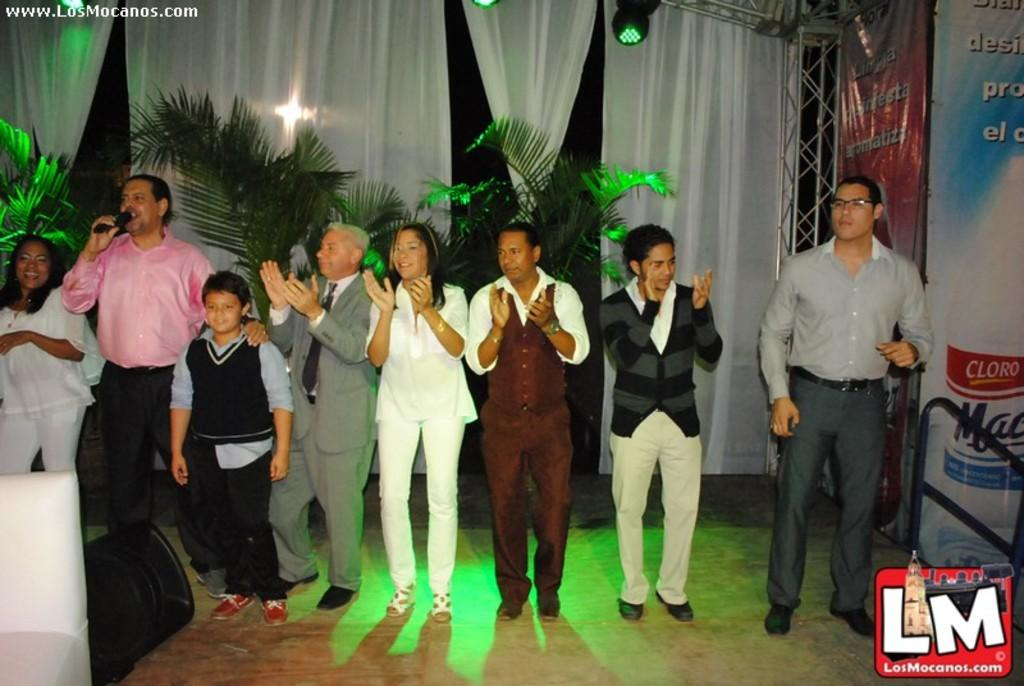How many people are in the image? There are persons in the image, but the exact number is not specified. What are some of the people doing in the image? Some of the persons are clapping. What object is being held by one of the persons? One person is holding a microphone. What type of clothing can be seen in the background of the image? There are pants in the background of the image. What type of window treatment is visible in the background of the image? There are curtains in the background of the image. What is located at the top of the image? There are lights at the top of the image. How many children are wearing skirts in the image? There is no mention of children or skirts in the image, so this question cannot be answered definitively. What type of ear is visible on the person holding the microphone? There is no information about the person's ears in the image, so this question cannot be answered definitively. 